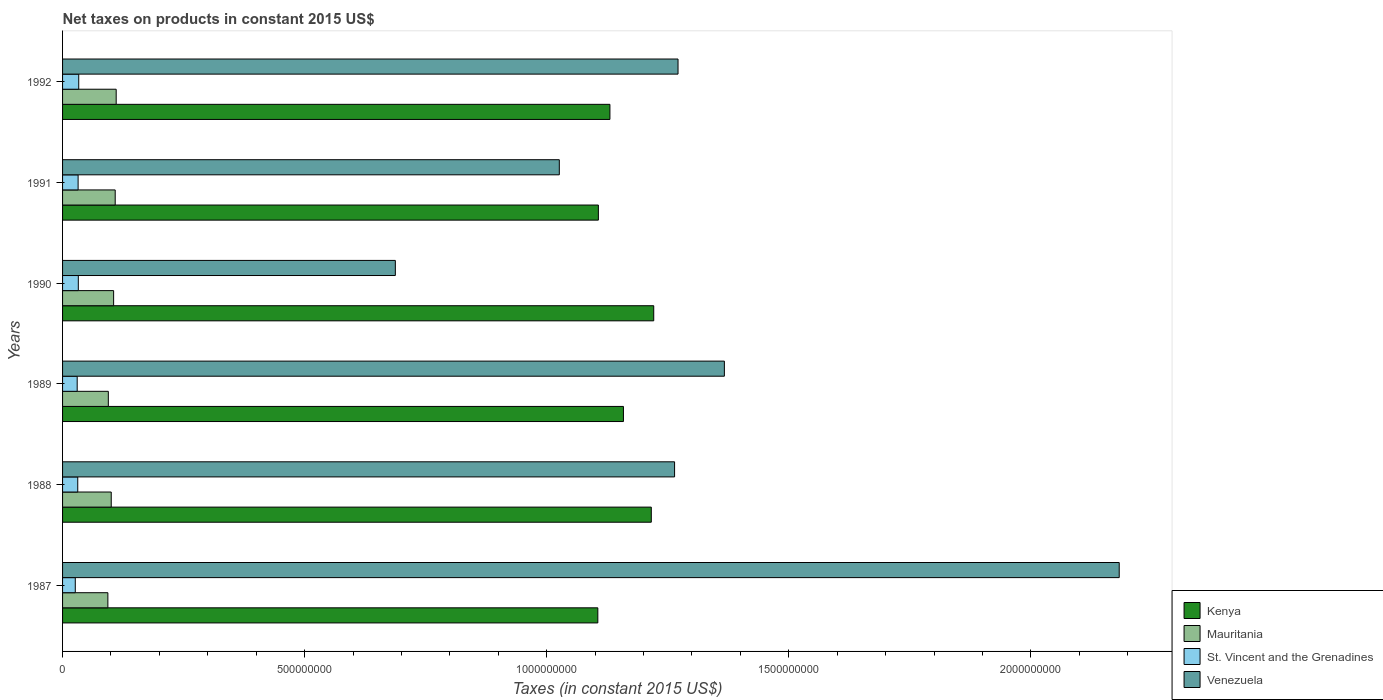How many different coloured bars are there?
Offer a terse response. 4. Are the number of bars per tick equal to the number of legend labels?
Provide a short and direct response. Yes. Are the number of bars on each tick of the Y-axis equal?
Offer a very short reply. Yes. How many bars are there on the 1st tick from the top?
Provide a succinct answer. 4. What is the net taxes on products in Venezuela in 1990?
Your answer should be very brief. 6.87e+08. Across all years, what is the maximum net taxes on products in St. Vincent and the Grenadines?
Offer a very short reply. 3.34e+07. Across all years, what is the minimum net taxes on products in Mauritania?
Ensure brevity in your answer.  9.36e+07. In which year was the net taxes on products in Venezuela maximum?
Provide a short and direct response. 1987. What is the total net taxes on products in Venezuela in the graph?
Provide a succinct answer. 7.80e+09. What is the difference between the net taxes on products in St. Vincent and the Grenadines in 1989 and that in 1990?
Provide a succinct answer. -2.30e+06. What is the difference between the net taxes on products in Mauritania in 1988 and the net taxes on products in Kenya in 1989?
Your response must be concise. -1.06e+09. What is the average net taxes on products in Kenya per year?
Your response must be concise. 1.16e+09. In the year 1992, what is the difference between the net taxes on products in Venezuela and net taxes on products in Mauritania?
Make the answer very short. 1.16e+09. In how many years, is the net taxes on products in Venezuela greater than 1700000000 US$?
Your answer should be very brief. 1. What is the ratio of the net taxes on products in Mauritania in 1987 to that in 1990?
Give a very brief answer. 0.89. Is the net taxes on products in Venezuela in 1990 less than that in 1992?
Offer a very short reply. Yes. Is the difference between the net taxes on products in Venezuela in 1989 and 1991 greater than the difference between the net taxes on products in Mauritania in 1989 and 1991?
Offer a very short reply. Yes. What is the difference between the highest and the second highest net taxes on products in St. Vincent and the Grenadines?
Your answer should be very brief. 8.63e+05. What is the difference between the highest and the lowest net taxes on products in Kenya?
Offer a very short reply. 1.15e+08. Is it the case that in every year, the sum of the net taxes on products in Venezuela and net taxes on products in Kenya is greater than the sum of net taxes on products in St. Vincent and the Grenadines and net taxes on products in Mauritania?
Your answer should be compact. Yes. What does the 2nd bar from the top in 1992 represents?
Provide a succinct answer. St. Vincent and the Grenadines. What does the 2nd bar from the bottom in 1989 represents?
Your answer should be compact. Mauritania. Is it the case that in every year, the sum of the net taxes on products in Mauritania and net taxes on products in St. Vincent and the Grenadines is greater than the net taxes on products in Kenya?
Keep it short and to the point. No. How many bars are there?
Your response must be concise. 24. Are all the bars in the graph horizontal?
Provide a succinct answer. Yes. Are the values on the major ticks of X-axis written in scientific E-notation?
Offer a very short reply. No. Does the graph contain any zero values?
Give a very brief answer. No. Where does the legend appear in the graph?
Offer a terse response. Bottom right. How many legend labels are there?
Keep it short and to the point. 4. What is the title of the graph?
Offer a terse response. Net taxes on products in constant 2015 US$. Does "Turks and Caicos Islands" appear as one of the legend labels in the graph?
Offer a terse response. No. What is the label or title of the X-axis?
Keep it short and to the point. Taxes (in constant 2015 US$). What is the label or title of the Y-axis?
Provide a short and direct response. Years. What is the Taxes (in constant 2015 US$) in Kenya in 1987?
Give a very brief answer. 1.11e+09. What is the Taxes (in constant 2015 US$) of Mauritania in 1987?
Your answer should be very brief. 9.36e+07. What is the Taxes (in constant 2015 US$) of St. Vincent and the Grenadines in 1987?
Your answer should be very brief. 2.62e+07. What is the Taxes (in constant 2015 US$) of Venezuela in 1987?
Offer a terse response. 2.18e+09. What is the Taxes (in constant 2015 US$) in Kenya in 1988?
Offer a terse response. 1.22e+09. What is the Taxes (in constant 2015 US$) of Mauritania in 1988?
Provide a succinct answer. 1.01e+08. What is the Taxes (in constant 2015 US$) of St. Vincent and the Grenadines in 1988?
Ensure brevity in your answer.  3.14e+07. What is the Taxes (in constant 2015 US$) of Venezuela in 1988?
Your response must be concise. 1.26e+09. What is the Taxes (in constant 2015 US$) of Kenya in 1989?
Your answer should be compact. 1.16e+09. What is the Taxes (in constant 2015 US$) of Mauritania in 1989?
Provide a short and direct response. 9.45e+07. What is the Taxes (in constant 2015 US$) in St. Vincent and the Grenadines in 1989?
Provide a succinct answer. 3.02e+07. What is the Taxes (in constant 2015 US$) in Venezuela in 1989?
Your answer should be very brief. 1.37e+09. What is the Taxes (in constant 2015 US$) in Kenya in 1990?
Keep it short and to the point. 1.22e+09. What is the Taxes (in constant 2015 US$) in Mauritania in 1990?
Make the answer very short. 1.05e+08. What is the Taxes (in constant 2015 US$) in St. Vincent and the Grenadines in 1990?
Offer a very short reply. 3.25e+07. What is the Taxes (in constant 2015 US$) in Venezuela in 1990?
Provide a short and direct response. 6.87e+08. What is the Taxes (in constant 2015 US$) in Kenya in 1991?
Offer a terse response. 1.11e+09. What is the Taxes (in constant 2015 US$) in Mauritania in 1991?
Keep it short and to the point. 1.09e+08. What is the Taxes (in constant 2015 US$) in St. Vincent and the Grenadines in 1991?
Your answer should be very brief. 3.21e+07. What is the Taxes (in constant 2015 US$) of Venezuela in 1991?
Your answer should be compact. 1.03e+09. What is the Taxes (in constant 2015 US$) of Kenya in 1992?
Your answer should be very brief. 1.13e+09. What is the Taxes (in constant 2015 US$) in Mauritania in 1992?
Give a very brief answer. 1.11e+08. What is the Taxes (in constant 2015 US$) in St. Vincent and the Grenadines in 1992?
Ensure brevity in your answer.  3.34e+07. What is the Taxes (in constant 2015 US$) in Venezuela in 1992?
Make the answer very short. 1.27e+09. Across all years, what is the maximum Taxes (in constant 2015 US$) in Kenya?
Give a very brief answer. 1.22e+09. Across all years, what is the maximum Taxes (in constant 2015 US$) of Mauritania?
Give a very brief answer. 1.11e+08. Across all years, what is the maximum Taxes (in constant 2015 US$) in St. Vincent and the Grenadines?
Offer a very short reply. 3.34e+07. Across all years, what is the maximum Taxes (in constant 2015 US$) in Venezuela?
Provide a succinct answer. 2.18e+09. Across all years, what is the minimum Taxes (in constant 2015 US$) in Kenya?
Your answer should be compact. 1.11e+09. Across all years, what is the minimum Taxes (in constant 2015 US$) of Mauritania?
Ensure brevity in your answer.  9.36e+07. Across all years, what is the minimum Taxes (in constant 2015 US$) of St. Vincent and the Grenadines?
Keep it short and to the point. 2.62e+07. Across all years, what is the minimum Taxes (in constant 2015 US$) of Venezuela?
Offer a terse response. 6.87e+08. What is the total Taxes (in constant 2015 US$) in Kenya in the graph?
Offer a very short reply. 6.94e+09. What is the total Taxes (in constant 2015 US$) of Mauritania in the graph?
Keep it short and to the point. 6.14e+08. What is the total Taxes (in constant 2015 US$) of St. Vincent and the Grenadines in the graph?
Provide a succinct answer. 1.86e+08. What is the total Taxes (in constant 2015 US$) of Venezuela in the graph?
Your answer should be compact. 7.80e+09. What is the difference between the Taxes (in constant 2015 US$) in Kenya in 1987 and that in 1988?
Your answer should be compact. -1.10e+08. What is the difference between the Taxes (in constant 2015 US$) in Mauritania in 1987 and that in 1988?
Make the answer very short. -6.94e+06. What is the difference between the Taxes (in constant 2015 US$) in St. Vincent and the Grenadines in 1987 and that in 1988?
Keep it short and to the point. -5.11e+06. What is the difference between the Taxes (in constant 2015 US$) of Venezuela in 1987 and that in 1988?
Keep it short and to the point. 9.18e+08. What is the difference between the Taxes (in constant 2015 US$) of Kenya in 1987 and that in 1989?
Ensure brevity in your answer.  -5.29e+07. What is the difference between the Taxes (in constant 2015 US$) in Mauritania in 1987 and that in 1989?
Your answer should be very brief. -9.46e+05. What is the difference between the Taxes (in constant 2015 US$) of St. Vincent and the Grenadines in 1987 and that in 1989?
Make the answer very short. -3.97e+06. What is the difference between the Taxes (in constant 2015 US$) in Venezuela in 1987 and that in 1989?
Give a very brief answer. 8.16e+08. What is the difference between the Taxes (in constant 2015 US$) in Kenya in 1987 and that in 1990?
Your answer should be compact. -1.15e+08. What is the difference between the Taxes (in constant 2015 US$) of Mauritania in 1987 and that in 1990?
Provide a short and direct response. -1.19e+07. What is the difference between the Taxes (in constant 2015 US$) in St. Vincent and the Grenadines in 1987 and that in 1990?
Your answer should be very brief. -6.27e+06. What is the difference between the Taxes (in constant 2015 US$) in Venezuela in 1987 and that in 1990?
Offer a terse response. 1.50e+09. What is the difference between the Taxes (in constant 2015 US$) in Kenya in 1987 and that in 1991?
Your answer should be very brief. -1.12e+06. What is the difference between the Taxes (in constant 2015 US$) in Mauritania in 1987 and that in 1991?
Offer a terse response. -1.51e+07. What is the difference between the Taxes (in constant 2015 US$) in St. Vincent and the Grenadines in 1987 and that in 1991?
Provide a short and direct response. -5.86e+06. What is the difference between the Taxes (in constant 2015 US$) of Venezuela in 1987 and that in 1991?
Offer a terse response. 1.16e+09. What is the difference between the Taxes (in constant 2015 US$) in Kenya in 1987 and that in 1992?
Your answer should be very brief. -2.50e+07. What is the difference between the Taxes (in constant 2015 US$) in Mauritania in 1987 and that in 1992?
Your answer should be compact. -1.71e+07. What is the difference between the Taxes (in constant 2015 US$) of St. Vincent and the Grenadines in 1987 and that in 1992?
Make the answer very short. -7.13e+06. What is the difference between the Taxes (in constant 2015 US$) of Venezuela in 1987 and that in 1992?
Offer a very short reply. 9.11e+08. What is the difference between the Taxes (in constant 2015 US$) in Kenya in 1988 and that in 1989?
Ensure brevity in your answer.  5.75e+07. What is the difference between the Taxes (in constant 2015 US$) of Mauritania in 1988 and that in 1989?
Provide a short and direct response. 6.00e+06. What is the difference between the Taxes (in constant 2015 US$) of St. Vincent and the Grenadines in 1988 and that in 1989?
Your answer should be compact. 1.15e+06. What is the difference between the Taxes (in constant 2015 US$) of Venezuela in 1988 and that in 1989?
Offer a terse response. -1.03e+08. What is the difference between the Taxes (in constant 2015 US$) in Kenya in 1988 and that in 1990?
Provide a succinct answer. -5.03e+06. What is the difference between the Taxes (in constant 2015 US$) of Mauritania in 1988 and that in 1990?
Keep it short and to the point. -4.92e+06. What is the difference between the Taxes (in constant 2015 US$) of St. Vincent and the Grenadines in 1988 and that in 1990?
Ensure brevity in your answer.  -1.16e+06. What is the difference between the Taxes (in constant 2015 US$) of Venezuela in 1988 and that in 1990?
Offer a terse response. 5.77e+08. What is the difference between the Taxes (in constant 2015 US$) of Kenya in 1988 and that in 1991?
Your response must be concise. 1.09e+08. What is the difference between the Taxes (in constant 2015 US$) in Mauritania in 1988 and that in 1991?
Offer a very short reply. -8.19e+06. What is the difference between the Taxes (in constant 2015 US$) of St. Vincent and the Grenadines in 1988 and that in 1991?
Provide a succinct answer. -7.48e+05. What is the difference between the Taxes (in constant 2015 US$) of Venezuela in 1988 and that in 1991?
Offer a very short reply. 2.38e+08. What is the difference between the Taxes (in constant 2015 US$) in Kenya in 1988 and that in 1992?
Give a very brief answer. 8.55e+07. What is the difference between the Taxes (in constant 2015 US$) in Mauritania in 1988 and that in 1992?
Your answer should be compact. -1.02e+07. What is the difference between the Taxes (in constant 2015 US$) of St. Vincent and the Grenadines in 1988 and that in 1992?
Keep it short and to the point. -2.02e+06. What is the difference between the Taxes (in constant 2015 US$) of Venezuela in 1988 and that in 1992?
Your response must be concise. -7.13e+06. What is the difference between the Taxes (in constant 2015 US$) of Kenya in 1989 and that in 1990?
Your response must be concise. -6.26e+07. What is the difference between the Taxes (in constant 2015 US$) in Mauritania in 1989 and that in 1990?
Ensure brevity in your answer.  -1.09e+07. What is the difference between the Taxes (in constant 2015 US$) in St. Vincent and the Grenadines in 1989 and that in 1990?
Keep it short and to the point. -2.30e+06. What is the difference between the Taxes (in constant 2015 US$) of Venezuela in 1989 and that in 1990?
Keep it short and to the point. 6.80e+08. What is the difference between the Taxes (in constant 2015 US$) of Kenya in 1989 and that in 1991?
Your response must be concise. 5.18e+07. What is the difference between the Taxes (in constant 2015 US$) in Mauritania in 1989 and that in 1991?
Offer a very short reply. -1.42e+07. What is the difference between the Taxes (in constant 2015 US$) in St. Vincent and the Grenadines in 1989 and that in 1991?
Give a very brief answer. -1.90e+06. What is the difference between the Taxes (in constant 2015 US$) of Venezuela in 1989 and that in 1991?
Keep it short and to the point. 3.41e+08. What is the difference between the Taxes (in constant 2015 US$) in Kenya in 1989 and that in 1992?
Your response must be concise. 2.79e+07. What is the difference between the Taxes (in constant 2015 US$) of Mauritania in 1989 and that in 1992?
Provide a short and direct response. -1.62e+07. What is the difference between the Taxes (in constant 2015 US$) of St. Vincent and the Grenadines in 1989 and that in 1992?
Your answer should be compact. -3.17e+06. What is the difference between the Taxes (in constant 2015 US$) in Venezuela in 1989 and that in 1992?
Ensure brevity in your answer.  9.57e+07. What is the difference between the Taxes (in constant 2015 US$) of Kenya in 1990 and that in 1991?
Your answer should be very brief. 1.14e+08. What is the difference between the Taxes (in constant 2015 US$) of Mauritania in 1990 and that in 1991?
Make the answer very short. -3.27e+06. What is the difference between the Taxes (in constant 2015 US$) of St. Vincent and the Grenadines in 1990 and that in 1991?
Provide a short and direct response. 4.07e+05. What is the difference between the Taxes (in constant 2015 US$) in Venezuela in 1990 and that in 1991?
Offer a terse response. -3.39e+08. What is the difference between the Taxes (in constant 2015 US$) in Kenya in 1990 and that in 1992?
Ensure brevity in your answer.  9.05e+07. What is the difference between the Taxes (in constant 2015 US$) in Mauritania in 1990 and that in 1992?
Provide a succinct answer. -5.29e+06. What is the difference between the Taxes (in constant 2015 US$) of St. Vincent and the Grenadines in 1990 and that in 1992?
Offer a terse response. -8.63e+05. What is the difference between the Taxes (in constant 2015 US$) of Venezuela in 1990 and that in 1992?
Provide a short and direct response. -5.84e+08. What is the difference between the Taxes (in constant 2015 US$) of Kenya in 1991 and that in 1992?
Offer a terse response. -2.38e+07. What is the difference between the Taxes (in constant 2015 US$) in Mauritania in 1991 and that in 1992?
Your answer should be compact. -2.02e+06. What is the difference between the Taxes (in constant 2015 US$) of St. Vincent and the Grenadines in 1991 and that in 1992?
Make the answer very short. -1.27e+06. What is the difference between the Taxes (in constant 2015 US$) of Venezuela in 1991 and that in 1992?
Offer a terse response. -2.45e+08. What is the difference between the Taxes (in constant 2015 US$) of Kenya in 1987 and the Taxes (in constant 2015 US$) of Mauritania in 1988?
Provide a succinct answer. 1.01e+09. What is the difference between the Taxes (in constant 2015 US$) in Kenya in 1987 and the Taxes (in constant 2015 US$) in St. Vincent and the Grenadines in 1988?
Give a very brief answer. 1.07e+09. What is the difference between the Taxes (in constant 2015 US$) of Kenya in 1987 and the Taxes (in constant 2015 US$) of Venezuela in 1988?
Provide a short and direct response. -1.59e+08. What is the difference between the Taxes (in constant 2015 US$) in Mauritania in 1987 and the Taxes (in constant 2015 US$) in St. Vincent and the Grenadines in 1988?
Provide a succinct answer. 6.22e+07. What is the difference between the Taxes (in constant 2015 US$) of Mauritania in 1987 and the Taxes (in constant 2015 US$) of Venezuela in 1988?
Offer a terse response. -1.17e+09. What is the difference between the Taxes (in constant 2015 US$) of St. Vincent and the Grenadines in 1987 and the Taxes (in constant 2015 US$) of Venezuela in 1988?
Your answer should be compact. -1.24e+09. What is the difference between the Taxes (in constant 2015 US$) in Kenya in 1987 and the Taxes (in constant 2015 US$) in Mauritania in 1989?
Provide a succinct answer. 1.01e+09. What is the difference between the Taxes (in constant 2015 US$) in Kenya in 1987 and the Taxes (in constant 2015 US$) in St. Vincent and the Grenadines in 1989?
Your answer should be very brief. 1.08e+09. What is the difference between the Taxes (in constant 2015 US$) in Kenya in 1987 and the Taxes (in constant 2015 US$) in Venezuela in 1989?
Your answer should be very brief. -2.61e+08. What is the difference between the Taxes (in constant 2015 US$) of Mauritania in 1987 and the Taxes (in constant 2015 US$) of St. Vincent and the Grenadines in 1989?
Your answer should be very brief. 6.34e+07. What is the difference between the Taxes (in constant 2015 US$) of Mauritania in 1987 and the Taxes (in constant 2015 US$) of Venezuela in 1989?
Give a very brief answer. -1.27e+09. What is the difference between the Taxes (in constant 2015 US$) of St. Vincent and the Grenadines in 1987 and the Taxes (in constant 2015 US$) of Venezuela in 1989?
Provide a succinct answer. -1.34e+09. What is the difference between the Taxes (in constant 2015 US$) in Kenya in 1987 and the Taxes (in constant 2015 US$) in Mauritania in 1990?
Your answer should be very brief. 1.00e+09. What is the difference between the Taxes (in constant 2015 US$) in Kenya in 1987 and the Taxes (in constant 2015 US$) in St. Vincent and the Grenadines in 1990?
Your answer should be compact. 1.07e+09. What is the difference between the Taxes (in constant 2015 US$) of Kenya in 1987 and the Taxes (in constant 2015 US$) of Venezuela in 1990?
Give a very brief answer. 4.18e+08. What is the difference between the Taxes (in constant 2015 US$) of Mauritania in 1987 and the Taxes (in constant 2015 US$) of St. Vincent and the Grenadines in 1990?
Provide a succinct answer. 6.11e+07. What is the difference between the Taxes (in constant 2015 US$) in Mauritania in 1987 and the Taxes (in constant 2015 US$) in Venezuela in 1990?
Provide a succinct answer. -5.94e+08. What is the difference between the Taxes (in constant 2015 US$) of St. Vincent and the Grenadines in 1987 and the Taxes (in constant 2015 US$) of Venezuela in 1990?
Provide a short and direct response. -6.61e+08. What is the difference between the Taxes (in constant 2015 US$) in Kenya in 1987 and the Taxes (in constant 2015 US$) in Mauritania in 1991?
Your answer should be compact. 9.97e+08. What is the difference between the Taxes (in constant 2015 US$) of Kenya in 1987 and the Taxes (in constant 2015 US$) of St. Vincent and the Grenadines in 1991?
Offer a terse response. 1.07e+09. What is the difference between the Taxes (in constant 2015 US$) in Kenya in 1987 and the Taxes (in constant 2015 US$) in Venezuela in 1991?
Provide a succinct answer. 7.96e+07. What is the difference between the Taxes (in constant 2015 US$) in Mauritania in 1987 and the Taxes (in constant 2015 US$) in St. Vincent and the Grenadines in 1991?
Provide a succinct answer. 6.15e+07. What is the difference between the Taxes (in constant 2015 US$) of Mauritania in 1987 and the Taxes (in constant 2015 US$) of Venezuela in 1991?
Give a very brief answer. -9.32e+08. What is the difference between the Taxes (in constant 2015 US$) in St. Vincent and the Grenadines in 1987 and the Taxes (in constant 2015 US$) in Venezuela in 1991?
Your answer should be compact. -1.00e+09. What is the difference between the Taxes (in constant 2015 US$) in Kenya in 1987 and the Taxes (in constant 2015 US$) in Mauritania in 1992?
Offer a very short reply. 9.95e+08. What is the difference between the Taxes (in constant 2015 US$) of Kenya in 1987 and the Taxes (in constant 2015 US$) of St. Vincent and the Grenadines in 1992?
Offer a very short reply. 1.07e+09. What is the difference between the Taxes (in constant 2015 US$) in Kenya in 1987 and the Taxes (in constant 2015 US$) in Venezuela in 1992?
Provide a short and direct response. -1.66e+08. What is the difference between the Taxes (in constant 2015 US$) in Mauritania in 1987 and the Taxes (in constant 2015 US$) in St. Vincent and the Grenadines in 1992?
Make the answer very short. 6.02e+07. What is the difference between the Taxes (in constant 2015 US$) in Mauritania in 1987 and the Taxes (in constant 2015 US$) in Venezuela in 1992?
Ensure brevity in your answer.  -1.18e+09. What is the difference between the Taxes (in constant 2015 US$) in St. Vincent and the Grenadines in 1987 and the Taxes (in constant 2015 US$) in Venezuela in 1992?
Offer a very short reply. -1.24e+09. What is the difference between the Taxes (in constant 2015 US$) of Kenya in 1988 and the Taxes (in constant 2015 US$) of Mauritania in 1989?
Offer a terse response. 1.12e+09. What is the difference between the Taxes (in constant 2015 US$) of Kenya in 1988 and the Taxes (in constant 2015 US$) of St. Vincent and the Grenadines in 1989?
Offer a terse response. 1.19e+09. What is the difference between the Taxes (in constant 2015 US$) of Kenya in 1988 and the Taxes (in constant 2015 US$) of Venezuela in 1989?
Ensure brevity in your answer.  -1.51e+08. What is the difference between the Taxes (in constant 2015 US$) in Mauritania in 1988 and the Taxes (in constant 2015 US$) in St. Vincent and the Grenadines in 1989?
Your response must be concise. 7.03e+07. What is the difference between the Taxes (in constant 2015 US$) in Mauritania in 1988 and the Taxes (in constant 2015 US$) in Venezuela in 1989?
Keep it short and to the point. -1.27e+09. What is the difference between the Taxes (in constant 2015 US$) in St. Vincent and the Grenadines in 1988 and the Taxes (in constant 2015 US$) in Venezuela in 1989?
Your response must be concise. -1.34e+09. What is the difference between the Taxes (in constant 2015 US$) of Kenya in 1988 and the Taxes (in constant 2015 US$) of Mauritania in 1990?
Offer a terse response. 1.11e+09. What is the difference between the Taxes (in constant 2015 US$) in Kenya in 1988 and the Taxes (in constant 2015 US$) in St. Vincent and the Grenadines in 1990?
Ensure brevity in your answer.  1.18e+09. What is the difference between the Taxes (in constant 2015 US$) in Kenya in 1988 and the Taxes (in constant 2015 US$) in Venezuela in 1990?
Keep it short and to the point. 5.29e+08. What is the difference between the Taxes (in constant 2015 US$) in Mauritania in 1988 and the Taxes (in constant 2015 US$) in St. Vincent and the Grenadines in 1990?
Offer a terse response. 6.80e+07. What is the difference between the Taxes (in constant 2015 US$) of Mauritania in 1988 and the Taxes (in constant 2015 US$) of Venezuela in 1990?
Provide a short and direct response. -5.87e+08. What is the difference between the Taxes (in constant 2015 US$) in St. Vincent and the Grenadines in 1988 and the Taxes (in constant 2015 US$) in Venezuela in 1990?
Make the answer very short. -6.56e+08. What is the difference between the Taxes (in constant 2015 US$) of Kenya in 1988 and the Taxes (in constant 2015 US$) of Mauritania in 1991?
Provide a succinct answer. 1.11e+09. What is the difference between the Taxes (in constant 2015 US$) in Kenya in 1988 and the Taxes (in constant 2015 US$) in St. Vincent and the Grenadines in 1991?
Provide a succinct answer. 1.18e+09. What is the difference between the Taxes (in constant 2015 US$) of Kenya in 1988 and the Taxes (in constant 2015 US$) of Venezuela in 1991?
Provide a succinct answer. 1.90e+08. What is the difference between the Taxes (in constant 2015 US$) in Mauritania in 1988 and the Taxes (in constant 2015 US$) in St. Vincent and the Grenadines in 1991?
Ensure brevity in your answer.  6.84e+07. What is the difference between the Taxes (in constant 2015 US$) of Mauritania in 1988 and the Taxes (in constant 2015 US$) of Venezuela in 1991?
Your answer should be very brief. -9.25e+08. What is the difference between the Taxes (in constant 2015 US$) in St. Vincent and the Grenadines in 1988 and the Taxes (in constant 2015 US$) in Venezuela in 1991?
Keep it short and to the point. -9.95e+08. What is the difference between the Taxes (in constant 2015 US$) in Kenya in 1988 and the Taxes (in constant 2015 US$) in Mauritania in 1992?
Your response must be concise. 1.11e+09. What is the difference between the Taxes (in constant 2015 US$) of Kenya in 1988 and the Taxes (in constant 2015 US$) of St. Vincent and the Grenadines in 1992?
Make the answer very short. 1.18e+09. What is the difference between the Taxes (in constant 2015 US$) in Kenya in 1988 and the Taxes (in constant 2015 US$) in Venezuela in 1992?
Provide a succinct answer. -5.52e+07. What is the difference between the Taxes (in constant 2015 US$) in Mauritania in 1988 and the Taxes (in constant 2015 US$) in St. Vincent and the Grenadines in 1992?
Give a very brief answer. 6.71e+07. What is the difference between the Taxes (in constant 2015 US$) in Mauritania in 1988 and the Taxes (in constant 2015 US$) in Venezuela in 1992?
Keep it short and to the point. -1.17e+09. What is the difference between the Taxes (in constant 2015 US$) of St. Vincent and the Grenadines in 1988 and the Taxes (in constant 2015 US$) of Venezuela in 1992?
Ensure brevity in your answer.  -1.24e+09. What is the difference between the Taxes (in constant 2015 US$) of Kenya in 1989 and the Taxes (in constant 2015 US$) of Mauritania in 1990?
Make the answer very short. 1.05e+09. What is the difference between the Taxes (in constant 2015 US$) of Kenya in 1989 and the Taxes (in constant 2015 US$) of St. Vincent and the Grenadines in 1990?
Offer a terse response. 1.13e+09. What is the difference between the Taxes (in constant 2015 US$) in Kenya in 1989 and the Taxes (in constant 2015 US$) in Venezuela in 1990?
Make the answer very short. 4.71e+08. What is the difference between the Taxes (in constant 2015 US$) in Mauritania in 1989 and the Taxes (in constant 2015 US$) in St. Vincent and the Grenadines in 1990?
Ensure brevity in your answer.  6.20e+07. What is the difference between the Taxes (in constant 2015 US$) in Mauritania in 1989 and the Taxes (in constant 2015 US$) in Venezuela in 1990?
Make the answer very short. -5.93e+08. What is the difference between the Taxes (in constant 2015 US$) in St. Vincent and the Grenadines in 1989 and the Taxes (in constant 2015 US$) in Venezuela in 1990?
Your answer should be very brief. -6.57e+08. What is the difference between the Taxes (in constant 2015 US$) of Kenya in 1989 and the Taxes (in constant 2015 US$) of Mauritania in 1991?
Your answer should be very brief. 1.05e+09. What is the difference between the Taxes (in constant 2015 US$) of Kenya in 1989 and the Taxes (in constant 2015 US$) of St. Vincent and the Grenadines in 1991?
Offer a terse response. 1.13e+09. What is the difference between the Taxes (in constant 2015 US$) of Kenya in 1989 and the Taxes (in constant 2015 US$) of Venezuela in 1991?
Offer a very short reply. 1.32e+08. What is the difference between the Taxes (in constant 2015 US$) in Mauritania in 1989 and the Taxes (in constant 2015 US$) in St. Vincent and the Grenadines in 1991?
Ensure brevity in your answer.  6.24e+07. What is the difference between the Taxes (in constant 2015 US$) of Mauritania in 1989 and the Taxes (in constant 2015 US$) of Venezuela in 1991?
Provide a short and direct response. -9.31e+08. What is the difference between the Taxes (in constant 2015 US$) of St. Vincent and the Grenadines in 1989 and the Taxes (in constant 2015 US$) of Venezuela in 1991?
Offer a very short reply. -9.96e+08. What is the difference between the Taxes (in constant 2015 US$) in Kenya in 1989 and the Taxes (in constant 2015 US$) in Mauritania in 1992?
Your answer should be very brief. 1.05e+09. What is the difference between the Taxes (in constant 2015 US$) of Kenya in 1989 and the Taxes (in constant 2015 US$) of St. Vincent and the Grenadines in 1992?
Keep it short and to the point. 1.13e+09. What is the difference between the Taxes (in constant 2015 US$) in Kenya in 1989 and the Taxes (in constant 2015 US$) in Venezuela in 1992?
Provide a short and direct response. -1.13e+08. What is the difference between the Taxes (in constant 2015 US$) of Mauritania in 1989 and the Taxes (in constant 2015 US$) of St. Vincent and the Grenadines in 1992?
Your answer should be very brief. 6.12e+07. What is the difference between the Taxes (in constant 2015 US$) in Mauritania in 1989 and the Taxes (in constant 2015 US$) in Venezuela in 1992?
Offer a terse response. -1.18e+09. What is the difference between the Taxes (in constant 2015 US$) in St. Vincent and the Grenadines in 1989 and the Taxes (in constant 2015 US$) in Venezuela in 1992?
Your answer should be very brief. -1.24e+09. What is the difference between the Taxes (in constant 2015 US$) of Kenya in 1990 and the Taxes (in constant 2015 US$) of Mauritania in 1991?
Ensure brevity in your answer.  1.11e+09. What is the difference between the Taxes (in constant 2015 US$) of Kenya in 1990 and the Taxes (in constant 2015 US$) of St. Vincent and the Grenadines in 1991?
Your response must be concise. 1.19e+09. What is the difference between the Taxes (in constant 2015 US$) in Kenya in 1990 and the Taxes (in constant 2015 US$) in Venezuela in 1991?
Your answer should be very brief. 1.95e+08. What is the difference between the Taxes (in constant 2015 US$) in Mauritania in 1990 and the Taxes (in constant 2015 US$) in St. Vincent and the Grenadines in 1991?
Your response must be concise. 7.33e+07. What is the difference between the Taxes (in constant 2015 US$) of Mauritania in 1990 and the Taxes (in constant 2015 US$) of Venezuela in 1991?
Provide a short and direct response. -9.21e+08. What is the difference between the Taxes (in constant 2015 US$) in St. Vincent and the Grenadines in 1990 and the Taxes (in constant 2015 US$) in Venezuela in 1991?
Keep it short and to the point. -9.93e+08. What is the difference between the Taxes (in constant 2015 US$) in Kenya in 1990 and the Taxes (in constant 2015 US$) in Mauritania in 1992?
Ensure brevity in your answer.  1.11e+09. What is the difference between the Taxes (in constant 2015 US$) in Kenya in 1990 and the Taxes (in constant 2015 US$) in St. Vincent and the Grenadines in 1992?
Offer a very short reply. 1.19e+09. What is the difference between the Taxes (in constant 2015 US$) in Kenya in 1990 and the Taxes (in constant 2015 US$) in Venezuela in 1992?
Ensure brevity in your answer.  -5.02e+07. What is the difference between the Taxes (in constant 2015 US$) in Mauritania in 1990 and the Taxes (in constant 2015 US$) in St. Vincent and the Grenadines in 1992?
Your answer should be compact. 7.21e+07. What is the difference between the Taxes (in constant 2015 US$) in Mauritania in 1990 and the Taxes (in constant 2015 US$) in Venezuela in 1992?
Keep it short and to the point. -1.17e+09. What is the difference between the Taxes (in constant 2015 US$) of St. Vincent and the Grenadines in 1990 and the Taxes (in constant 2015 US$) of Venezuela in 1992?
Provide a succinct answer. -1.24e+09. What is the difference between the Taxes (in constant 2015 US$) in Kenya in 1991 and the Taxes (in constant 2015 US$) in Mauritania in 1992?
Provide a succinct answer. 9.96e+08. What is the difference between the Taxes (in constant 2015 US$) of Kenya in 1991 and the Taxes (in constant 2015 US$) of St. Vincent and the Grenadines in 1992?
Your answer should be very brief. 1.07e+09. What is the difference between the Taxes (in constant 2015 US$) of Kenya in 1991 and the Taxes (in constant 2015 US$) of Venezuela in 1992?
Your answer should be very brief. -1.65e+08. What is the difference between the Taxes (in constant 2015 US$) of Mauritania in 1991 and the Taxes (in constant 2015 US$) of St. Vincent and the Grenadines in 1992?
Your answer should be very brief. 7.53e+07. What is the difference between the Taxes (in constant 2015 US$) of Mauritania in 1991 and the Taxes (in constant 2015 US$) of Venezuela in 1992?
Provide a short and direct response. -1.16e+09. What is the difference between the Taxes (in constant 2015 US$) in St. Vincent and the Grenadines in 1991 and the Taxes (in constant 2015 US$) in Venezuela in 1992?
Ensure brevity in your answer.  -1.24e+09. What is the average Taxes (in constant 2015 US$) of Kenya per year?
Offer a terse response. 1.16e+09. What is the average Taxes (in constant 2015 US$) in Mauritania per year?
Your answer should be compact. 1.02e+08. What is the average Taxes (in constant 2015 US$) of St. Vincent and the Grenadines per year?
Your response must be concise. 3.10e+07. What is the average Taxes (in constant 2015 US$) of Venezuela per year?
Give a very brief answer. 1.30e+09. In the year 1987, what is the difference between the Taxes (in constant 2015 US$) of Kenya and Taxes (in constant 2015 US$) of Mauritania?
Your answer should be compact. 1.01e+09. In the year 1987, what is the difference between the Taxes (in constant 2015 US$) of Kenya and Taxes (in constant 2015 US$) of St. Vincent and the Grenadines?
Your answer should be very brief. 1.08e+09. In the year 1987, what is the difference between the Taxes (in constant 2015 US$) of Kenya and Taxes (in constant 2015 US$) of Venezuela?
Provide a short and direct response. -1.08e+09. In the year 1987, what is the difference between the Taxes (in constant 2015 US$) in Mauritania and Taxes (in constant 2015 US$) in St. Vincent and the Grenadines?
Keep it short and to the point. 6.73e+07. In the year 1987, what is the difference between the Taxes (in constant 2015 US$) in Mauritania and Taxes (in constant 2015 US$) in Venezuela?
Offer a terse response. -2.09e+09. In the year 1987, what is the difference between the Taxes (in constant 2015 US$) in St. Vincent and the Grenadines and Taxes (in constant 2015 US$) in Venezuela?
Your answer should be very brief. -2.16e+09. In the year 1988, what is the difference between the Taxes (in constant 2015 US$) of Kenya and Taxes (in constant 2015 US$) of Mauritania?
Make the answer very short. 1.12e+09. In the year 1988, what is the difference between the Taxes (in constant 2015 US$) in Kenya and Taxes (in constant 2015 US$) in St. Vincent and the Grenadines?
Your answer should be very brief. 1.18e+09. In the year 1988, what is the difference between the Taxes (in constant 2015 US$) in Kenya and Taxes (in constant 2015 US$) in Venezuela?
Your response must be concise. -4.81e+07. In the year 1988, what is the difference between the Taxes (in constant 2015 US$) in Mauritania and Taxes (in constant 2015 US$) in St. Vincent and the Grenadines?
Offer a terse response. 6.92e+07. In the year 1988, what is the difference between the Taxes (in constant 2015 US$) of Mauritania and Taxes (in constant 2015 US$) of Venezuela?
Your answer should be compact. -1.16e+09. In the year 1988, what is the difference between the Taxes (in constant 2015 US$) in St. Vincent and the Grenadines and Taxes (in constant 2015 US$) in Venezuela?
Keep it short and to the point. -1.23e+09. In the year 1989, what is the difference between the Taxes (in constant 2015 US$) of Kenya and Taxes (in constant 2015 US$) of Mauritania?
Make the answer very short. 1.06e+09. In the year 1989, what is the difference between the Taxes (in constant 2015 US$) of Kenya and Taxes (in constant 2015 US$) of St. Vincent and the Grenadines?
Offer a terse response. 1.13e+09. In the year 1989, what is the difference between the Taxes (in constant 2015 US$) of Kenya and Taxes (in constant 2015 US$) of Venezuela?
Keep it short and to the point. -2.08e+08. In the year 1989, what is the difference between the Taxes (in constant 2015 US$) in Mauritania and Taxes (in constant 2015 US$) in St. Vincent and the Grenadines?
Provide a succinct answer. 6.43e+07. In the year 1989, what is the difference between the Taxes (in constant 2015 US$) in Mauritania and Taxes (in constant 2015 US$) in Venezuela?
Your answer should be compact. -1.27e+09. In the year 1989, what is the difference between the Taxes (in constant 2015 US$) of St. Vincent and the Grenadines and Taxes (in constant 2015 US$) of Venezuela?
Your answer should be very brief. -1.34e+09. In the year 1990, what is the difference between the Taxes (in constant 2015 US$) of Kenya and Taxes (in constant 2015 US$) of Mauritania?
Give a very brief answer. 1.12e+09. In the year 1990, what is the difference between the Taxes (in constant 2015 US$) of Kenya and Taxes (in constant 2015 US$) of St. Vincent and the Grenadines?
Make the answer very short. 1.19e+09. In the year 1990, what is the difference between the Taxes (in constant 2015 US$) of Kenya and Taxes (in constant 2015 US$) of Venezuela?
Your answer should be very brief. 5.34e+08. In the year 1990, what is the difference between the Taxes (in constant 2015 US$) of Mauritania and Taxes (in constant 2015 US$) of St. Vincent and the Grenadines?
Keep it short and to the point. 7.29e+07. In the year 1990, what is the difference between the Taxes (in constant 2015 US$) of Mauritania and Taxes (in constant 2015 US$) of Venezuela?
Offer a terse response. -5.82e+08. In the year 1990, what is the difference between the Taxes (in constant 2015 US$) of St. Vincent and the Grenadines and Taxes (in constant 2015 US$) of Venezuela?
Give a very brief answer. -6.55e+08. In the year 1991, what is the difference between the Taxes (in constant 2015 US$) in Kenya and Taxes (in constant 2015 US$) in Mauritania?
Keep it short and to the point. 9.98e+08. In the year 1991, what is the difference between the Taxes (in constant 2015 US$) of Kenya and Taxes (in constant 2015 US$) of St. Vincent and the Grenadines?
Your answer should be very brief. 1.07e+09. In the year 1991, what is the difference between the Taxes (in constant 2015 US$) of Kenya and Taxes (in constant 2015 US$) of Venezuela?
Your answer should be compact. 8.07e+07. In the year 1991, what is the difference between the Taxes (in constant 2015 US$) of Mauritania and Taxes (in constant 2015 US$) of St. Vincent and the Grenadines?
Ensure brevity in your answer.  7.66e+07. In the year 1991, what is the difference between the Taxes (in constant 2015 US$) of Mauritania and Taxes (in constant 2015 US$) of Venezuela?
Ensure brevity in your answer.  -9.17e+08. In the year 1991, what is the difference between the Taxes (in constant 2015 US$) of St. Vincent and the Grenadines and Taxes (in constant 2015 US$) of Venezuela?
Offer a very short reply. -9.94e+08. In the year 1992, what is the difference between the Taxes (in constant 2015 US$) of Kenya and Taxes (in constant 2015 US$) of Mauritania?
Ensure brevity in your answer.  1.02e+09. In the year 1992, what is the difference between the Taxes (in constant 2015 US$) in Kenya and Taxes (in constant 2015 US$) in St. Vincent and the Grenadines?
Your answer should be very brief. 1.10e+09. In the year 1992, what is the difference between the Taxes (in constant 2015 US$) of Kenya and Taxes (in constant 2015 US$) of Venezuela?
Provide a short and direct response. -1.41e+08. In the year 1992, what is the difference between the Taxes (in constant 2015 US$) in Mauritania and Taxes (in constant 2015 US$) in St. Vincent and the Grenadines?
Keep it short and to the point. 7.74e+07. In the year 1992, what is the difference between the Taxes (in constant 2015 US$) in Mauritania and Taxes (in constant 2015 US$) in Venezuela?
Your answer should be compact. -1.16e+09. In the year 1992, what is the difference between the Taxes (in constant 2015 US$) of St. Vincent and the Grenadines and Taxes (in constant 2015 US$) of Venezuela?
Your answer should be very brief. -1.24e+09. What is the ratio of the Taxes (in constant 2015 US$) in Kenya in 1987 to that in 1988?
Provide a succinct answer. 0.91. What is the ratio of the Taxes (in constant 2015 US$) in Mauritania in 1987 to that in 1988?
Provide a succinct answer. 0.93. What is the ratio of the Taxes (in constant 2015 US$) of St. Vincent and the Grenadines in 1987 to that in 1988?
Keep it short and to the point. 0.84. What is the ratio of the Taxes (in constant 2015 US$) in Venezuela in 1987 to that in 1988?
Provide a short and direct response. 1.73. What is the ratio of the Taxes (in constant 2015 US$) in Kenya in 1987 to that in 1989?
Make the answer very short. 0.95. What is the ratio of the Taxes (in constant 2015 US$) of St. Vincent and the Grenadines in 1987 to that in 1989?
Your answer should be compact. 0.87. What is the ratio of the Taxes (in constant 2015 US$) in Venezuela in 1987 to that in 1989?
Give a very brief answer. 1.6. What is the ratio of the Taxes (in constant 2015 US$) of Kenya in 1987 to that in 1990?
Ensure brevity in your answer.  0.91. What is the ratio of the Taxes (in constant 2015 US$) in Mauritania in 1987 to that in 1990?
Provide a succinct answer. 0.89. What is the ratio of the Taxes (in constant 2015 US$) in St. Vincent and the Grenadines in 1987 to that in 1990?
Give a very brief answer. 0.81. What is the ratio of the Taxes (in constant 2015 US$) in Venezuela in 1987 to that in 1990?
Give a very brief answer. 3.18. What is the ratio of the Taxes (in constant 2015 US$) of Kenya in 1987 to that in 1991?
Offer a very short reply. 1. What is the ratio of the Taxes (in constant 2015 US$) of Mauritania in 1987 to that in 1991?
Offer a terse response. 0.86. What is the ratio of the Taxes (in constant 2015 US$) of St. Vincent and the Grenadines in 1987 to that in 1991?
Ensure brevity in your answer.  0.82. What is the ratio of the Taxes (in constant 2015 US$) of Venezuela in 1987 to that in 1991?
Provide a succinct answer. 2.13. What is the ratio of the Taxes (in constant 2015 US$) in Kenya in 1987 to that in 1992?
Your answer should be very brief. 0.98. What is the ratio of the Taxes (in constant 2015 US$) of Mauritania in 1987 to that in 1992?
Make the answer very short. 0.85. What is the ratio of the Taxes (in constant 2015 US$) in St. Vincent and the Grenadines in 1987 to that in 1992?
Your response must be concise. 0.79. What is the ratio of the Taxes (in constant 2015 US$) in Venezuela in 1987 to that in 1992?
Your answer should be compact. 1.72. What is the ratio of the Taxes (in constant 2015 US$) in Kenya in 1988 to that in 1989?
Ensure brevity in your answer.  1.05. What is the ratio of the Taxes (in constant 2015 US$) of Mauritania in 1988 to that in 1989?
Your answer should be very brief. 1.06. What is the ratio of the Taxes (in constant 2015 US$) in St. Vincent and the Grenadines in 1988 to that in 1989?
Give a very brief answer. 1.04. What is the ratio of the Taxes (in constant 2015 US$) of Venezuela in 1988 to that in 1989?
Provide a succinct answer. 0.92. What is the ratio of the Taxes (in constant 2015 US$) of Mauritania in 1988 to that in 1990?
Your answer should be compact. 0.95. What is the ratio of the Taxes (in constant 2015 US$) of St. Vincent and the Grenadines in 1988 to that in 1990?
Your response must be concise. 0.96. What is the ratio of the Taxes (in constant 2015 US$) of Venezuela in 1988 to that in 1990?
Give a very brief answer. 1.84. What is the ratio of the Taxes (in constant 2015 US$) in Kenya in 1988 to that in 1991?
Your response must be concise. 1.1. What is the ratio of the Taxes (in constant 2015 US$) of Mauritania in 1988 to that in 1991?
Offer a terse response. 0.92. What is the ratio of the Taxes (in constant 2015 US$) in St. Vincent and the Grenadines in 1988 to that in 1991?
Give a very brief answer. 0.98. What is the ratio of the Taxes (in constant 2015 US$) of Venezuela in 1988 to that in 1991?
Your answer should be compact. 1.23. What is the ratio of the Taxes (in constant 2015 US$) in Kenya in 1988 to that in 1992?
Ensure brevity in your answer.  1.08. What is the ratio of the Taxes (in constant 2015 US$) of Mauritania in 1988 to that in 1992?
Offer a very short reply. 0.91. What is the ratio of the Taxes (in constant 2015 US$) of St. Vincent and the Grenadines in 1988 to that in 1992?
Give a very brief answer. 0.94. What is the ratio of the Taxes (in constant 2015 US$) of Venezuela in 1988 to that in 1992?
Your answer should be compact. 0.99. What is the ratio of the Taxes (in constant 2015 US$) in Kenya in 1989 to that in 1990?
Give a very brief answer. 0.95. What is the ratio of the Taxes (in constant 2015 US$) in Mauritania in 1989 to that in 1990?
Ensure brevity in your answer.  0.9. What is the ratio of the Taxes (in constant 2015 US$) of St. Vincent and the Grenadines in 1989 to that in 1990?
Provide a short and direct response. 0.93. What is the ratio of the Taxes (in constant 2015 US$) in Venezuela in 1989 to that in 1990?
Offer a very short reply. 1.99. What is the ratio of the Taxes (in constant 2015 US$) in Kenya in 1989 to that in 1991?
Provide a succinct answer. 1.05. What is the ratio of the Taxes (in constant 2015 US$) in Mauritania in 1989 to that in 1991?
Make the answer very short. 0.87. What is the ratio of the Taxes (in constant 2015 US$) of St. Vincent and the Grenadines in 1989 to that in 1991?
Provide a short and direct response. 0.94. What is the ratio of the Taxes (in constant 2015 US$) of Venezuela in 1989 to that in 1991?
Make the answer very short. 1.33. What is the ratio of the Taxes (in constant 2015 US$) of Kenya in 1989 to that in 1992?
Your answer should be compact. 1.02. What is the ratio of the Taxes (in constant 2015 US$) of Mauritania in 1989 to that in 1992?
Ensure brevity in your answer.  0.85. What is the ratio of the Taxes (in constant 2015 US$) of St. Vincent and the Grenadines in 1989 to that in 1992?
Offer a very short reply. 0.91. What is the ratio of the Taxes (in constant 2015 US$) of Venezuela in 1989 to that in 1992?
Offer a very short reply. 1.08. What is the ratio of the Taxes (in constant 2015 US$) of Kenya in 1990 to that in 1991?
Give a very brief answer. 1.1. What is the ratio of the Taxes (in constant 2015 US$) of Mauritania in 1990 to that in 1991?
Your answer should be very brief. 0.97. What is the ratio of the Taxes (in constant 2015 US$) of St. Vincent and the Grenadines in 1990 to that in 1991?
Your answer should be very brief. 1.01. What is the ratio of the Taxes (in constant 2015 US$) of Venezuela in 1990 to that in 1991?
Offer a terse response. 0.67. What is the ratio of the Taxes (in constant 2015 US$) of Kenya in 1990 to that in 1992?
Your answer should be compact. 1.08. What is the ratio of the Taxes (in constant 2015 US$) of Mauritania in 1990 to that in 1992?
Keep it short and to the point. 0.95. What is the ratio of the Taxes (in constant 2015 US$) in St. Vincent and the Grenadines in 1990 to that in 1992?
Your response must be concise. 0.97. What is the ratio of the Taxes (in constant 2015 US$) of Venezuela in 1990 to that in 1992?
Make the answer very short. 0.54. What is the ratio of the Taxes (in constant 2015 US$) of Kenya in 1991 to that in 1992?
Provide a succinct answer. 0.98. What is the ratio of the Taxes (in constant 2015 US$) in Mauritania in 1991 to that in 1992?
Offer a terse response. 0.98. What is the ratio of the Taxes (in constant 2015 US$) of St. Vincent and the Grenadines in 1991 to that in 1992?
Make the answer very short. 0.96. What is the ratio of the Taxes (in constant 2015 US$) of Venezuela in 1991 to that in 1992?
Your answer should be very brief. 0.81. What is the difference between the highest and the second highest Taxes (in constant 2015 US$) of Kenya?
Make the answer very short. 5.03e+06. What is the difference between the highest and the second highest Taxes (in constant 2015 US$) in Mauritania?
Offer a terse response. 2.02e+06. What is the difference between the highest and the second highest Taxes (in constant 2015 US$) in St. Vincent and the Grenadines?
Ensure brevity in your answer.  8.63e+05. What is the difference between the highest and the second highest Taxes (in constant 2015 US$) of Venezuela?
Ensure brevity in your answer.  8.16e+08. What is the difference between the highest and the lowest Taxes (in constant 2015 US$) of Kenya?
Make the answer very short. 1.15e+08. What is the difference between the highest and the lowest Taxes (in constant 2015 US$) of Mauritania?
Make the answer very short. 1.71e+07. What is the difference between the highest and the lowest Taxes (in constant 2015 US$) in St. Vincent and the Grenadines?
Your answer should be very brief. 7.13e+06. What is the difference between the highest and the lowest Taxes (in constant 2015 US$) of Venezuela?
Your response must be concise. 1.50e+09. 